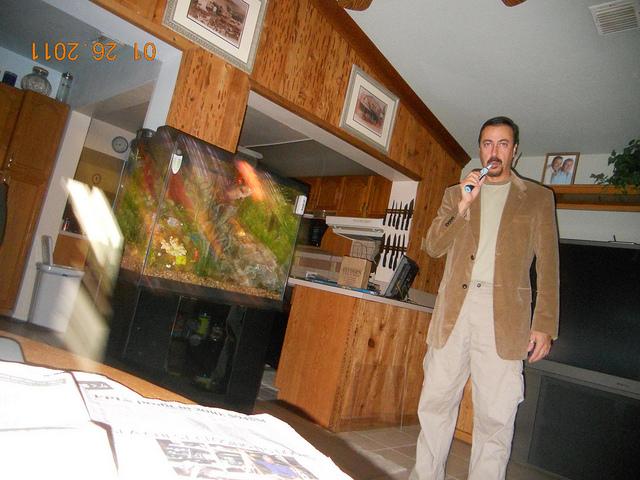How are the kitchen knives stored?
Keep it brief. On wall. What does the man wear over his shirt?
Write a very short answer. Jacket. What is the man doing?
Be succinct. Brushing teeth. 